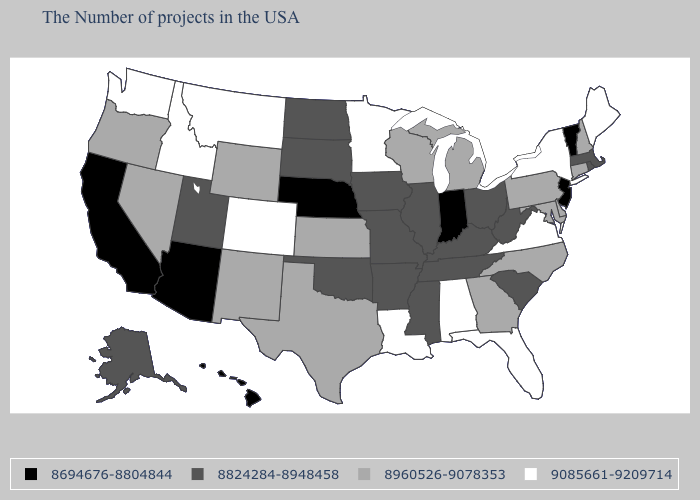Which states hav the highest value in the South?
Answer briefly. Virginia, Florida, Alabama, Louisiana. Does Louisiana have the highest value in the USA?
Answer briefly. Yes. What is the value of West Virginia?
Give a very brief answer. 8824284-8948458. Name the states that have a value in the range 8960526-9078353?
Keep it brief. New Hampshire, Connecticut, Delaware, Maryland, Pennsylvania, North Carolina, Georgia, Michigan, Wisconsin, Kansas, Texas, Wyoming, New Mexico, Nevada, Oregon. Which states have the lowest value in the USA?
Keep it brief. Vermont, New Jersey, Indiana, Nebraska, Arizona, California, Hawaii. Name the states that have a value in the range 9085661-9209714?
Write a very short answer. Maine, New York, Virginia, Florida, Alabama, Louisiana, Minnesota, Colorado, Montana, Idaho, Washington. Does the first symbol in the legend represent the smallest category?
Write a very short answer. Yes. What is the value of Missouri?
Answer briefly. 8824284-8948458. What is the value of Montana?
Write a very short answer. 9085661-9209714. What is the lowest value in the South?
Answer briefly. 8824284-8948458. What is the value of Utah?
Quick response, please. 8824284-8948458. Does New York have the highest value in the Northeast?
Short answer required. Yes. Does Idaho have a lower value than New Mexico?
Answer briefly. No. What is the value of California?
Keep it brief. 8694676-8804844. Which states have the lowest value in the South?
Answer briefly. South Carolina, West Virginia, Kentucky, Tennessee, Mississippi, Arkansas, Oklahoma. 